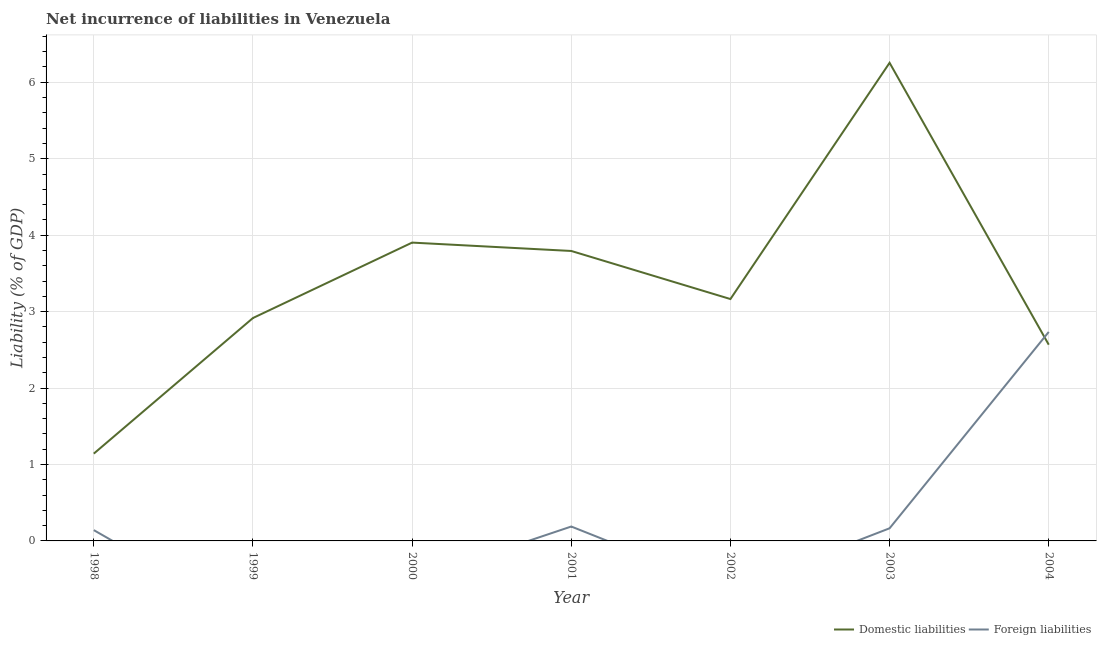What is the incurrence of domestic liabilities in 2001?
Offer a very short reply. 3.79. Across all years, what is the maximum incurrence of domestic liabilities?
Provide a short and direct response. 6.25. Across all years, what is the minimum incurrence of domestic liabilities?
Offer a very short reply. 1.14. What is the total incurrence of foreign liabilities in the graph?
Your answer should be very brief. 3.23. What is the difference between the incurrence of domestic liabilities in 2000 and that in 2001?
Offer a terse response. 0.11. What is the difference between the incurrence of foreign liabilities in 2004 and the incurrence of domestic liabilities in 2000?
Your response must be concise. -1.17. What is the average incurrence of foreign liabilities per year?
Provide a short and direct response. 0.46. In the year 2001, what is the difference between the incurrence of foreign liabilities and incurrence of domestic liabilities?
Offer a terse response. -3.6. What is the ratio of the incurrence of foreign liabilities in 2003 to that in 2004?
Ensure brevity in your answer.  0.06. Is the incurrence of foreign liabilities in 1998 less than that in 2004?
Ensure brevity in your answer.  Yes. What is the difference between the highest and the second highest incurrence of domestic liabilities?
Offer a terse response. 2.35. What is the difference between the highest and the lowest incurrence of domestic liabilities?
Your answer should be compact. 5.11. Is the sum of the incurrence of domestic liabilities in 1999 and 2001 greater than the maximum incurrence of foreign liabilities across all years?
Your answer should be compact. Yes. Does the incurrence of domestic liabilities monotonically increase over the years?
Offer a very short reply. No. Is the incurrence of domestic liabilities strictly greater than the incurrence of foreign liabilities over the years?
Your answer should be very brief. No. Is the incurrence of domestic liabilities strictly less than the incurrence of foreign liabilities over the years?
Offer a very short reply. No. How many years are there in the graph?
Offer a very short reply. 7. Are the values on the major ticks of Y-axis written in scientific E-notation?
Offer a terse response. No. Does the graph contain grids?
Offer a terse response. Yes. Where does the legend appear in the graph?
Offer a very short reply. Bottom right. How many legend labels are there?
Keep it short and to the point. 2. How are the legend labels stacked?
Offer a very short reply. Horizontal. What is the title of the graph?
Ensure brevity in your answer.  Net incurrence of liabilities in Venezuela. Does "Nitrous oxide" appear as one of the legend labels in the graph?
Ensure brevity in your answer.  No. What is the label or title of the Y-axis?
Keep it short and to the point. Liability (% of GDP). What is the Liability (% of GDP) in Domestic liabilities in 1998?
Offer a terse response. 1.14. What is the Liability (% of GDP) in Foreign liabilities in 1998?
Keep it short and to the point. 0.14. What is the Liability (% of GDP) of Domestic liabilities in 1999?
Make the answer very short. 2.92. What is the Liability (% of GDP) of Domestic liabilities in 2000?
Keep it short and to the point. 3.9. What is the Liability (% of GDP) of Domestic liabilities in 2001?
Provide a short and direct response. 3.79. What is the Liability (% of GDP) of Foreign liabilities in 2001?
Provide a short and direct response. 0.19. What is the Liability (% of GDP) in Domestic liabilities in 2002?
Your answer should be very brief. 3.16. What is the Liability (% of GDP) of Foreign liabilities in 2002?
Give a very brief answer. 0. What is the Liability (% of GDP) in Domestic liabilities in 2003?
Ensure brevity in your answer.  6.25. What is the Liability (% of GDP) in Foreign liabilities in 2003?
Your answer should be very brief. 0.17. What is the Liability (% of GDP) of Domestic liabilities in 2004?
Provide a short and direct response. 2.57. What is the Liability (% of GDP) of Foreign liabilities in 2004?
Your response must be concise. 2.73. Across all years, what is the maximum Liability (% of GDP) in Domestic liabilities?
Offer a terse response. 6.25. Across all years, what is the maximum Liability (% of GDP) in Foreign liabilities?
Offer a very short reply. 2.73. Across all years, what is the minimum Liability (% of GDP) of Domestic liabilities?
Provide a succinct answer. 1.14. What is the total Liability (% of GDP) in Domestic liabilities in the graph?
Give a very brief answer. 23.74. What is the total Liability (% of GDP) in Foreign liabilities in the graph?
Give a very brief answer. 3.23. What is the difference between the Liability (% of GDP) of Domestic liabilities in 1998 and that in 1999?
Offer a very short reply. -1.77. What is the difference between the Liability (% of GDP) of Domestic liabilities in 1998 and that in 2000?
Offer a very short reply. -2.76. What is the difference between the Liability (% of GDP) of Domestic liabilities in 1998 and that in 2001?
Your answer should be compact. -2.65. What is the difference between the Liability (% of GDP) in Foreign liabilities in 1998 and that in 2001?
Give a very brief answer. -0.05. What is the difference between the Liability (% of GDP) of Domestic liabilities in 1998 and that in 2002?
Your answer should be compact. -2.02. What is the difference between the Liability (% of GDP) in Domestic liabilities in 1998 and that in 2003?
Keep it short and to the point. -5.11. What is the difference between the Liability (% of GDP) in Foreign liabilities in 1998 and that in 2003?
Offer a terse response. -0.02. What is the difference between the Liability (% of GDP) of Domestic liabilities in 1998 and that in 2004?
Keep it short and to the point. -1.43. What is the difference between the Liability (% of GDP) in Foreign liabilities in 1998 and that in 2004?
Ensure brevity in your answer.  -2.59. What is the difference between the Liability (% of GDP) of Domestic liabilities in 1999 and that in 2000?
Offer a very short reply. -0.99. What is the difference between the Liability (% of GDP) in Domestic liabilities in 1999 and that in 2001?
Ensure brevity in your answer.  -0.88. What is the difference between the Liability (% of GDP) of Domestic liabilities in 1999 and that in 2002?
Provide a short and direct response. -0.25. What is the difference between the Liability (% of GDP) of Domestic liabilities in 1999 and that in 2003?
Your response must be concise. -3.34. What is the difference between the Liability (% of GDP) of Domestic liabilities in 1999 and that in 2004?
Give a very brief answer. 0.35. What is the difference between the Liability (% of GDP) of Domestic liabilities in 2000 and that in 2001?
Give a very brief answer. 0.11. What is the difference between the Liability (% of GDP) of Domestic liabilities in 2000 and that in 2002?
Ensure brevity in your answer.  0.74. What is the difference between the Liability (% of GDP) in Domestic liabilities in 2000 and that in 2003?
Your answer should be compact. -2.35. What is the difference between the Liability (% of GDP) in Domestic liabilities in 2000 and that in 2004?
Provide a short and direct response. 1.34. What is the difference between the Liability (% of GDP) of Domestic liabilities in 2001 and that in 2002?
Keep it short and to the point. 0.63. What is the difference between the Liability (% of GDP) in Domestic liabilities in 2001 and that in 2003?
Your response must be concise. -2.46. What is the difference between the Liability (% of GDP) in Foreign liabilities in 2001 and that in 2003?
Give a very brief answer. 0.02. What is the difference between the Liability (% of GDP) of Domestic liabilities in 2001 and that in 2004?
Provide a succinct answer. 1.23. What is the difference between the Liability (% of GDP) in Foreign liabilities in 2001 and that in 2004?
Offer a very short reply. -2.55. What is the difference between the Liability (% of GDP) of Domestic liabilities in 2002 and that in 2003?
Your answer should be very brief. -3.09. What is the difference between the Liability (% of GDP) in Domestic liabilities in 2002 and that in 2004?
Offer a terse response. 0.6. What is the difference between the Liability (% of GDP) in Domestic liabilities in 2003 and that in 2004?
Provide a succinct answer. 3.69. What is the difference between the Liability (% of GDP) in Foreign liabilities in 2003 and that in 2004?
Your answer should be very brief. -2.57. What is the difference between the Liability (% of GDP) in Domestic liabilities in 1998 and the Liability (% of GDP) in Foreign liabilities in 2001?
Provide a short and direct response. 0.95. What is the difference between the Liability (% of GDP) of Domestic liabilities in 1998 and the Liability (% of GDP) of Foreign liabilities in 2003?
Ensure brevity in your answer.  0.98. What is the difference between the Liability (% of GDP) in Domestic liabilities in 1998 and the Liability (% of GDP) in Foreign liabilities in 2004?
Your answer should be compact. -1.59. What is the difference between the Liability (% of GDP) of Domestic liabilities in 1999 and the Liability (% of GDP) of Foreign liabilities in 2001?
Your response must be concise. 2.73. What is the difference between the Liability (% of GDP) in Domestic liabilities in 1999 and the Liability (% of GDP) in Foreign liabilities in 2003?
Ensure brevity in your answer.  2.75. What is the difference between the Liability (% of GDP) of Domestic liabilities in 1999 and the Liability (% of GDP) of Foreign liabilities in 2004?
Your answer should be compact. 0.18. What is the difference between the Liability (% of GDP) in Domestic liabilities in 2000 and the Liability (% of GDP) in Foreign liabilities in 2001?
Offer a terse response. 3.71. What is the difference between the Liability (% of GDP) of Domestic liabilities in 2000 and the Liability (% of GDP) of Foreign liabilities in 2003?
Keep it short and to the point. 3.74. What is the difference between the Liability (% of GDP) in Domestic liabilities in 2000 and the Liability (% of GDP) in Foreign liabilities in 2004?
Your answer should be compact. 1.17. What is the difference between the Liability (% of GDP) of Domestic liabilities in 2001 and the Liability (% of GDP) of Foreign liabilities in 2003?
Give a very brief answer. 3.63. What is the difference between the Liability (% of GDP) in Domestic liabilities in 2001 and the Liability (% of GDP) in Foreign liabilities in 2004?
Make the answer very short. 1.06. What is the difference between the Liability (% of GDP) in Domestic liabilities in 2002 and the Liability (% of GDP) in Foreign liabilities in 2003?
Offer a terse response. 3. What is the difference between the Liability (% of GDP) in Domestic liabilities in 2002 and the Liability (% of GDP) in Foreign liabilities in 2004?
Keep it short and to the point. 0.43. What is the difference between the Liability (% of GDP) in Domestic liabilities in 2003 and the Liability (% of GDP) in Foreign liabilities in 2004?
Ensure brevity in your answer.  3.52. What is the average Liability (% of GDP) of Domestic liabilities per year?
Offer a very short reply. 3.39. What is the average Liability (% of GDP) in Foreign liabilities per year?
Your response must be concise. 0.46. In the year 2001, what is the difference between the Liability (% of GDP) of Domestic liabilities and Liability (% of GDP) of Foreign liabilities?
Provide a succinct answer. 3.6. In the year 2003, what is the difference between the Liability (% of GDP) in Domestic liabilities and Liability (% of GDP) in Foreign liabilities?
Ensure brevity in your answer.  6.09. In the year 2004, what is the difference between the Liability (% of GDP) in Domestic liabilities and Liability (% of GDP) in Foreign liabilities?
Your answer should be compact. -0.17. What is the ratio of the Liability (% of GDP) in Domestic liabilities in 1998 to that in 1999?
Your response must be concise. 0.39. What is the ratio of the Liability (% of GDP) of Domestic liabilities in 1998 to that in 2000?
Your answer should be very brief. 0.29. What is the ratio of the Liability (% of GDP) of Domestic liabilities in 1998 to that in 2001?
Offer a very short reply. 0.3. What is the ratio of the Liability (% of GDP) of Foreign liabilities in 1998 to that in 2001?
Provide a short and direct response. 0.75. What is the ratio of the Liability (% of GDP) in Domestic liabilities in 1998 to that in 2002?
Provide a succinct answer. 0.36. What is the ratio of the Liability (% of GDP) of Domestic liabilities in 1998 to that in 2003?
Your answer should be very brief. 0.18. What is the ratio of the Liability (% of GDP) in Foreign liabilities in 1998 to that in 2003?
Your response must be concise. 0.86. What is the ratio of the Liability (% of GDP) in Domestic liabilities in 1998 to that in 2004?
Make the answer very short. 0.44. What is the ratio of the Liability (% of GDP) in Foreign liabilities in 1998 to that in 2004?
Ensure brevity in your answer.  0.05. What is the ratio of the Liability (% of GDP) of Domestic liabilities in 1999 to that in 2000?
Offer a very short reply. 0.75. What is the ratio of the Liability (% of GDP) in Domestic liabilities in 1999 to that in 2001?
Offer a very short reply. 0.77. What is the ratio of the Liability (% of GDP) in Domestic liabilities in 1999 to that in 2002?
Give a very brief answer. 0.92. What is the ratio of the Liability (% of GDP) in Domestic liabilities in 1999 to that in 2003?
Keep it short and to the point. 0.47. What is the ratio of the Liability (% of GDP) in Domestic liabilities in 1999 to that in 2004?
Offer a terse response. 1.14. What is the ratio of the Liability (% of GDP) of Domestic liabilities in 2000 to that in 2001?
Keep it short and to the point. 1.03. What is the ratio of the Liability (% of GDP) of Domestic liabilities in 2000 to that in 2002?
Make the answer very short. 1.23. What is the ratio of the Liability (% of GDP) of Domestic liabilities in 2000 to that in 2003?
Offer a very short reply. 0.62. What is the ratio of the Liability (% of GDP) of Domestic liabilities in 2000 to that in 2004?
Make the answer very short. 1.52. What is the ratio of the Liability (% of GDP) of Domestic liabilities in 2001 to that in 2002?
Your answer should be compact. 1.2. What is the ratio of the Liability (% of GDP) in Domestic liabilities in 2001 to that in 2003?
Offer a terse response. 0.61. What is the ratio of the Liability (% of GDP) in Foreign liabilities in 2001 to that in 2003?
Ensure brevity in your answer.  1.14. What is the ratio of the Liability (% of GDP) of Domestic liabilities in 2001 to that in 2004?
Your answer should be compact. 1.48. What is the ratio of the Liability (% of GDP) of Foreign liabilities in 2001 to that in 2004?
Keep it short and to the point. 0.07. What is the ratio of the Liability (% of GDP) of Domestic liabilities in 2002 to that in 2003?
Keep it short and to the point. 0.51. What is the ratio of the Liability (% of GDP) in Domestic liabilities in 2002 to that in 2004?
Your answer should be very brief. 1.23. What is the ratio of the Liability (% of GDP) in Domestic liabilities in 2003 to that in 2004?
Provide a short and direct response. 2.44. What is the ratio of the Liability (% of GDP) of Foreign liabilities in 2003 to that in 2004?
Your answer should be compact. 0.06. What is the difference between the highest and the second highest Liability (% of GDP) of Domestic liabilities?
Make the answer very short. 2.35. What is the difference between the highest and the second highest Liability (% of GDP) of Foreign liabilities?
Give a very brief answer. 2.55. What is the difference between the highest and the lowest Liability (% of GDP) in Domestic liabilities?
Your response must be concise. 5.11. What is the difference between the highest and the lowest Liability (% of GDP) of Foreign liabilities?
Offer a very short reply. 2.73. 